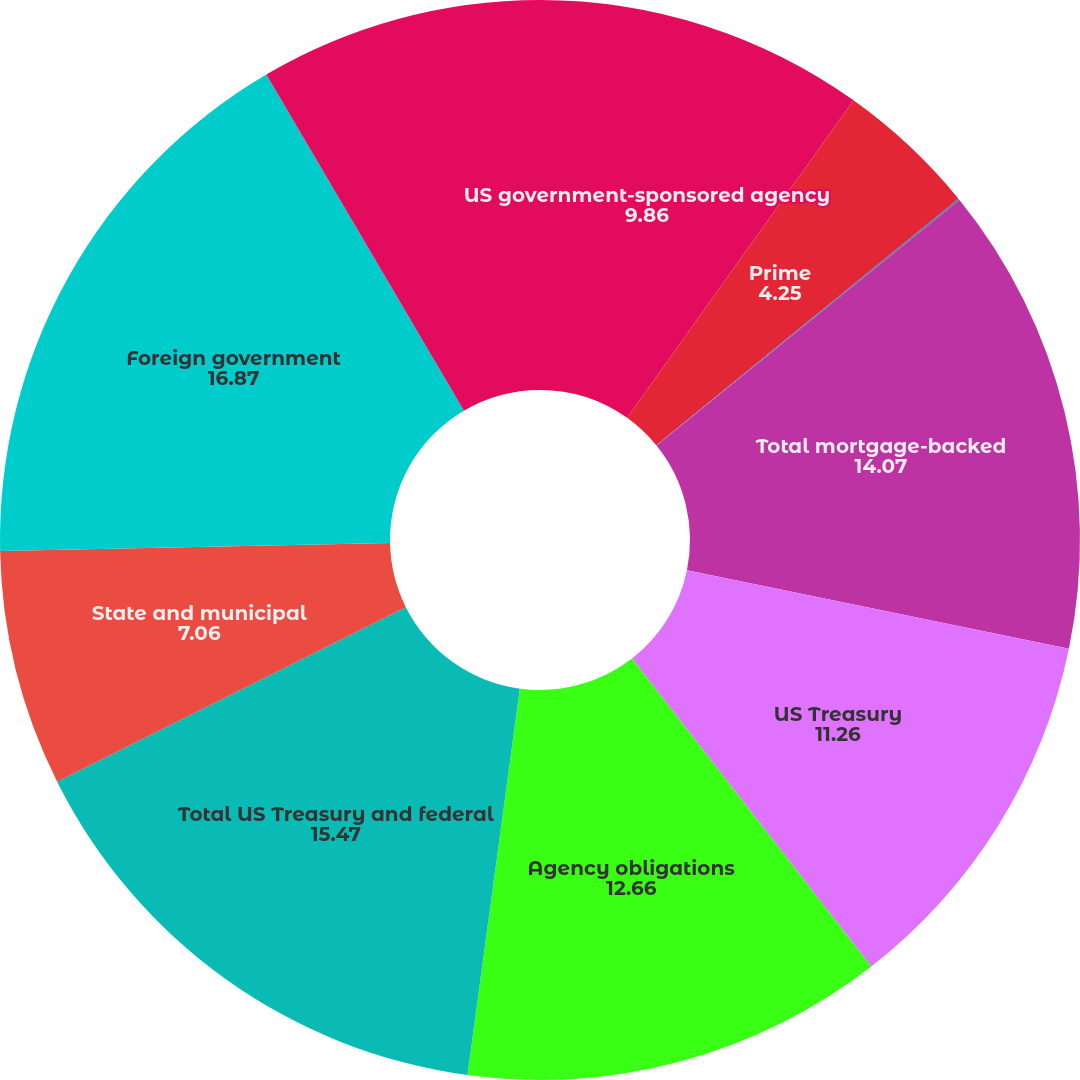Convert chart. <chart><loc_0><loc_0><loc_500><loc_500><pie_chart><fcel>US government-sponsored agency<fcel>Prime<fcel>Commercial<fcel>Total mortgage-backed<fcel>US Treasury<fcel>Agency obligations<fcel>Total US Treasury and federal<fcel>State and municipal<fcel>Foreign government<fcel>Corporate<nl><fcel>9.86%<fcel>4.25%<fcel>0.05%<fcel>14.07%<fcel>11.26%<fcel>12.66%<fcel>15.47%<fcel>7.06%<fcel>16.87%<fcel>8.46%<nl></chart> 